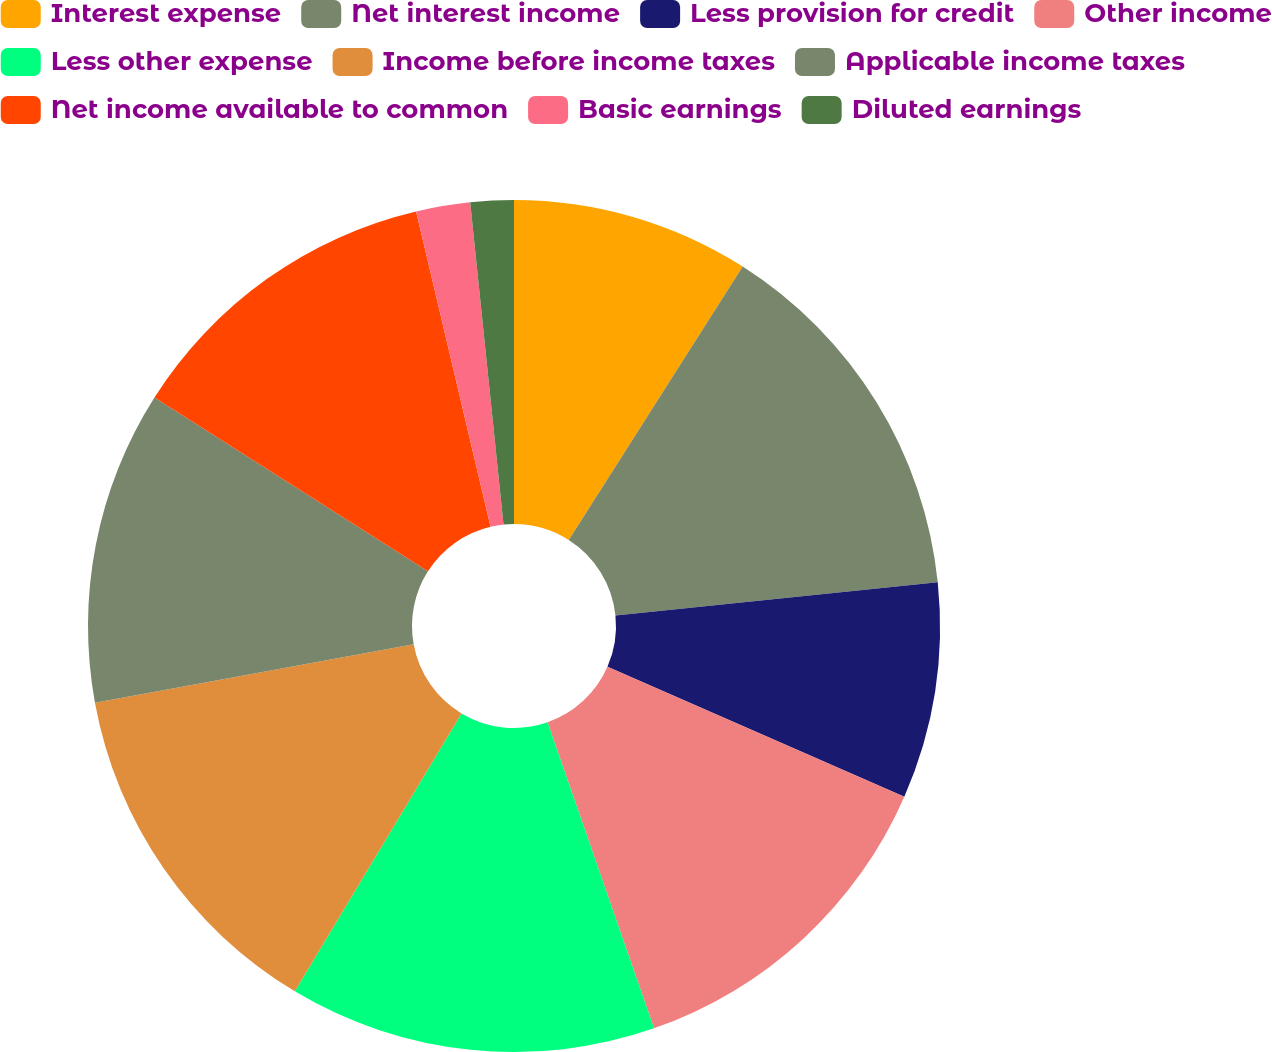Convert chart. <chart><loc_0><loc_0><loc_500><loc_500><pie_chart><fcel>Interest expense<fcel>Net interest income<fcel>Less provision for credit<fcel>Other income<fcel>Less other expense<fcel>Income before income taxes<fcel>Applicable income taxes<fcel>Net income available to common<fcel>Basic earnings<fcel>Diluted earnings<nl><fcel>9.02%<fcel>14.34%<fcel>8.2%<fcel>13.11%<fcel>13.93%<fcel>13.52%<fcel>11.89%<fcel>12.3%<fcel>2.05%<fcel>1.64%<nl></chart> 